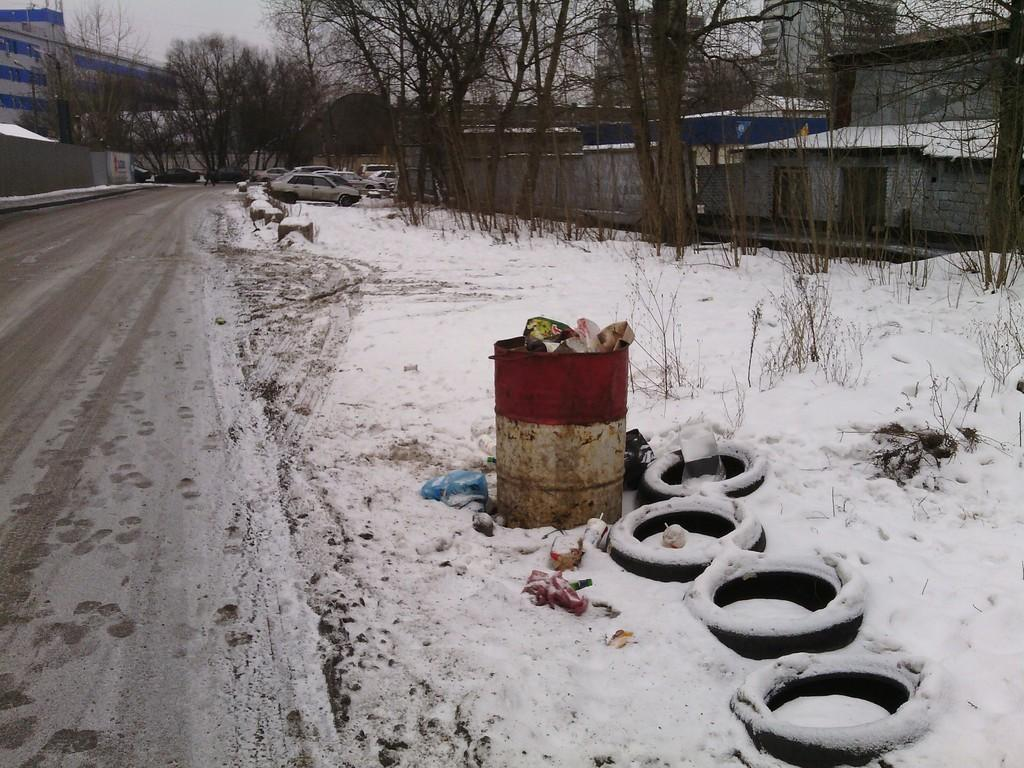What can be seen in the foreground of the image? In the foreground of the image, there is a path, a drum, a tire, and vehicles on the snow. What is located beside the path? There is a drum and a tire beside the path. What can be seen in the background of the image? In the background of the image, there are trees, buildings, and the sky. How many elements are present in the background of the image? There are three elements present in the background: trees, buildings, and the sky. What type of beef is being sold at the store in the image? There is no store or beef present in the image. Can you tell me how many cats are sitting on the tire in the image? There are no cats present in the image. 